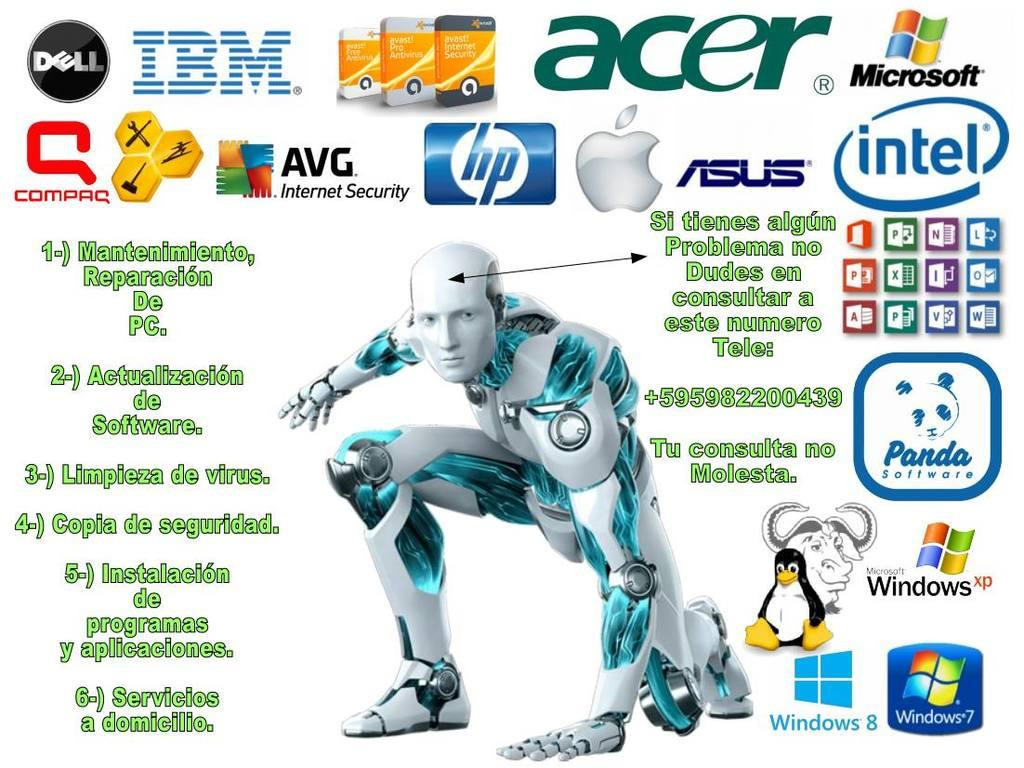What type of image is being described? The image is a poster. What is the main subject of the poster? There is a robot depicted on the poster. Are there any additional elements on the poster besides the robot? Yes, there are logos and text written on the poster. What type of food is being served on the poster? There is no food depicted on the poster; it features a robot and logos. Can you hear any noise coming from the poster? Posters are not capable of producing sound, so there is no noise coming from the poster. 